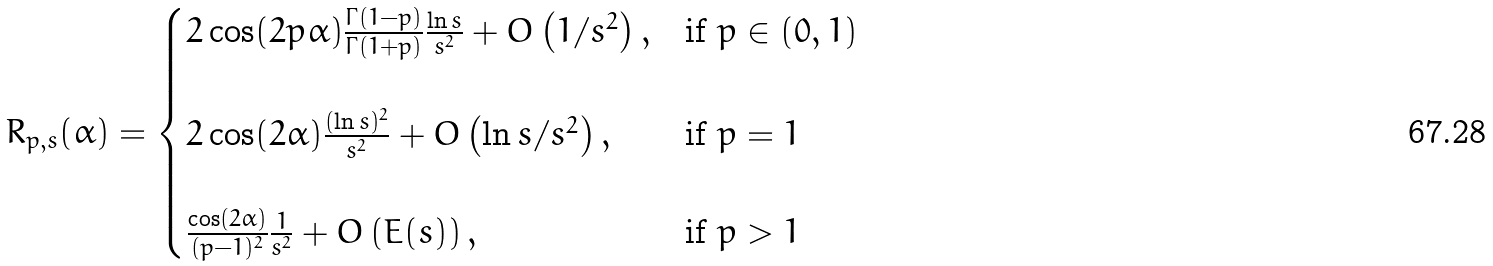Convert formula to latex. <formula><loc_0><loc_0><loc_500><loc_500>R _ { p , s } ( \alpha ) = \begin{cases} 2 \cos ( 2 p \alpha ) \frac { \Gamma ( 1 - p ) } { \Gamma ( 1 + p ) } \frac { \ln s } { s ^ { 2 } } + O \left ( 1 / s ^ { 2 } \right ) , & \text {if $p \in (0,1)$} \\ & \\ 2 \cos ( 2 \alpha ) \frac { ( \ln s ) ^ { 2 } } { s ^ { 2 } } + O \left ( \ln s / s ^ { 2 } \right ) , & \text {if $p=1$} \\ & \\ \frac { \cos ( 2 \alpha ) } { ( p - 1 ) ^ { 2 } } \frac { 1 } { s ^ { 2 } } + O \left ( E ( s ) \right ) , & \text {if $p>1$} \\ \end{cases}</formula> 